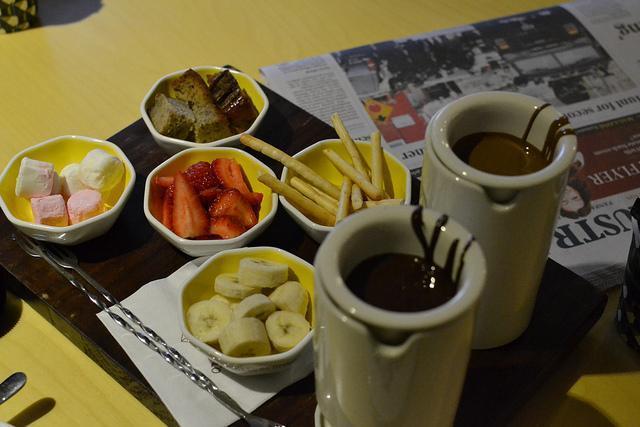How many bowls are in the picture?
Give a very brief answer. 5. How many cups are in the photo?
Give a very brief answer. 2. 